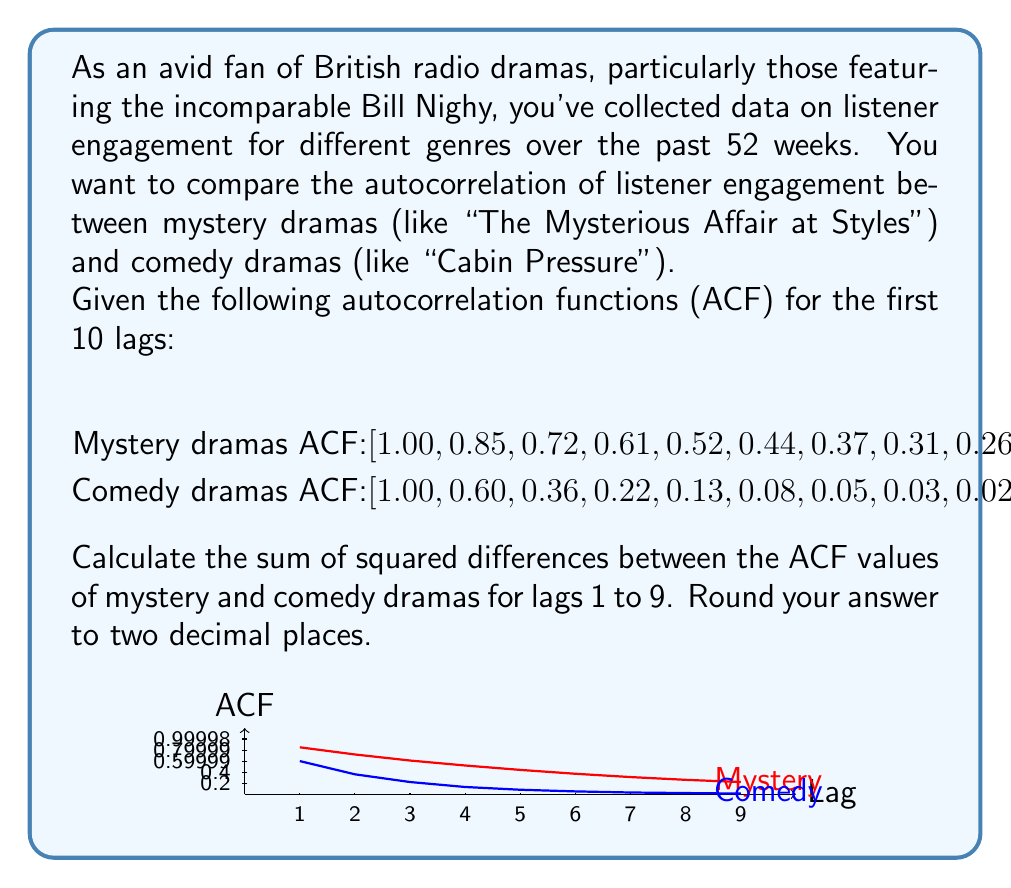Solve this math problem. Let's approach this step-by-step:

1) We need to calculate the difference between ACF values for each lag from 1 to 9, square these differences, and then sum them up.

2) Let's create a table to organize our calculations:

   Lag | Mystery ACF | Comedy ACF | Difference | Squared Difference
   1   | 0.85        | 0.60       | 0.25       | 0.0625
   2   | 0.72        | 0.36       | 0.36       | 0.1296
   3   | 0.61        | 0.22       | 0.39       | 0.1521
   4   | 0.52        | 0.13       | 0.39       | 0.1521
   5   | 0.44        | 0.08       | 0.36       | 0.1296
   6   | 0.37        | 0.05       | 0.32       | 0.1024
   7   | 0.31        | 0.03       | 0.28       | 0.0784
   8   | 0.26        | 0.02       | 0.24       | 0.0576
   9   | 0.22        | 0.01       | 0.21       | 0.0441

3) Now, let's sum up all the squared differences:

   $$ \sum_{i=1}^{9} (ACF_{mystery,i} - ACF_{comedy,i})^2 $$
   
   $$ = 0.0625 + 0.1296 + 0.1521 + 0.1521 + 0.1296 + 0.1024 + 0.0784 + 0.0576 + 0.0441 $$

4) Adding these up:

   $$ = 0.9084 $$

5) Rounding to two decimal places:

   $$ = 0.91 $$

This sum of squared differences gives us a measure of how different the autocorrelation structures are between the two genres. A larger value indicates more difference in the persistence of listener engagement over time.
Answer: 0.91 